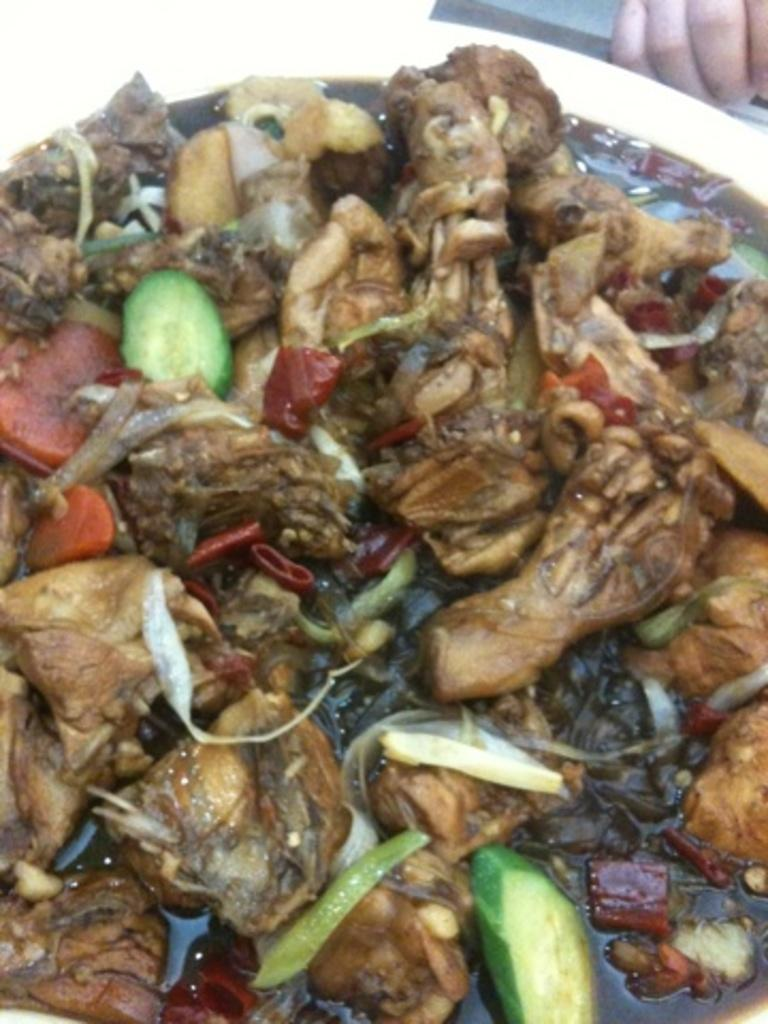What is the main subject in the center of the image? There is food in the center of the image. Can you describe any other elements in the image? Fingers of a person are visible at the top right corner of the image. What songs are being sung by the person in the frame? There is no person or frame present in the image, so it is not possible to determine what songs might be sung. 